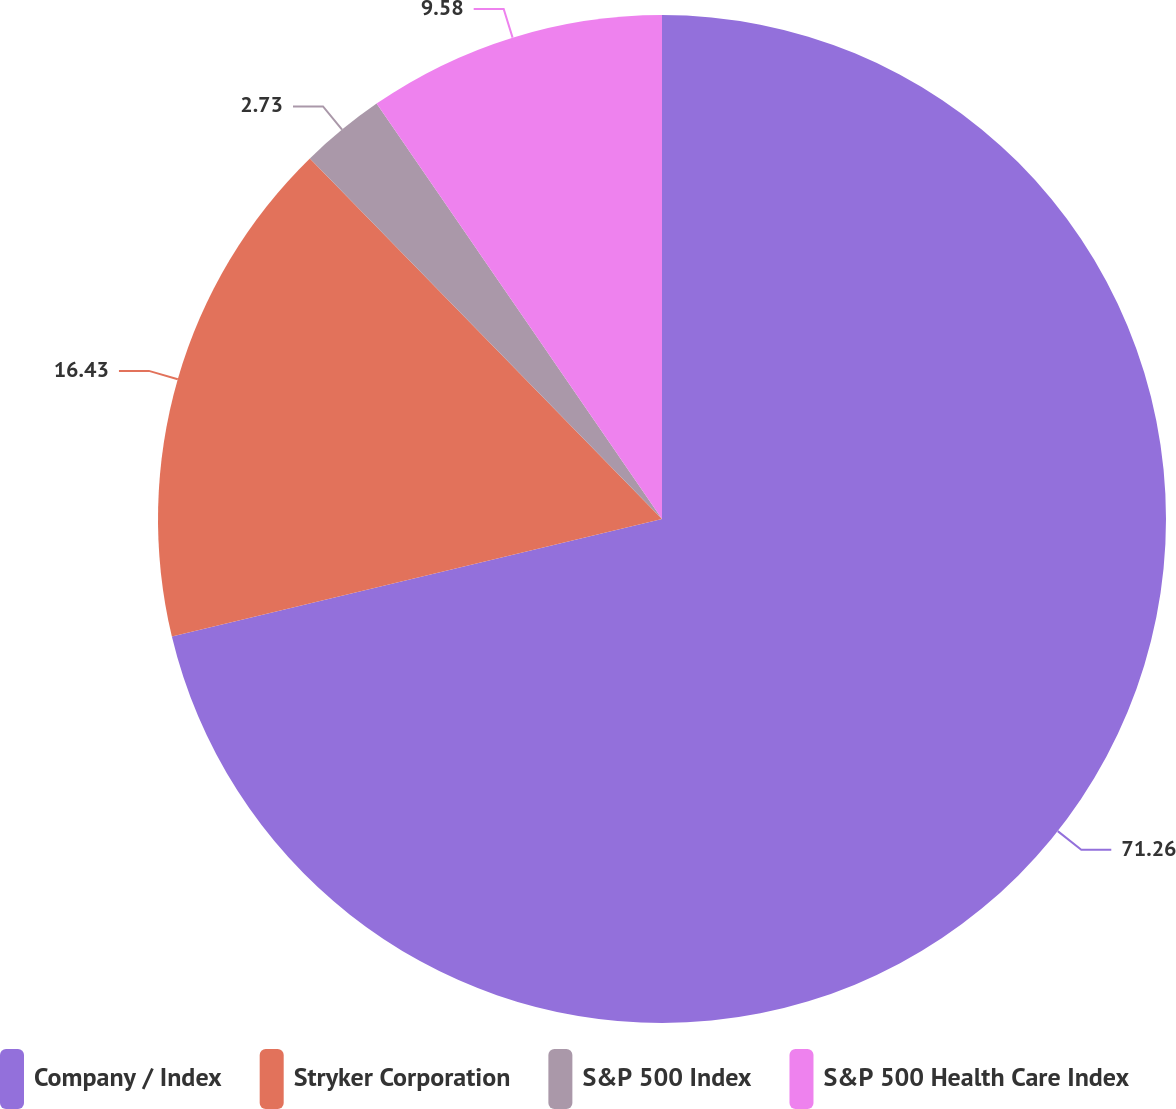Convert chart. <chart><loc_0><loc_0><loc_500><loc_500><pie_chart><fcel>Company / Index<fcel>Stryker Corporation<fcel>S&P 500 Index<fcel>S&P 500 Health Care Index<nl><fcel>71.25%<fcel>16.43%<fcel>2.73%<fcel>9.58%<nl></chart> 